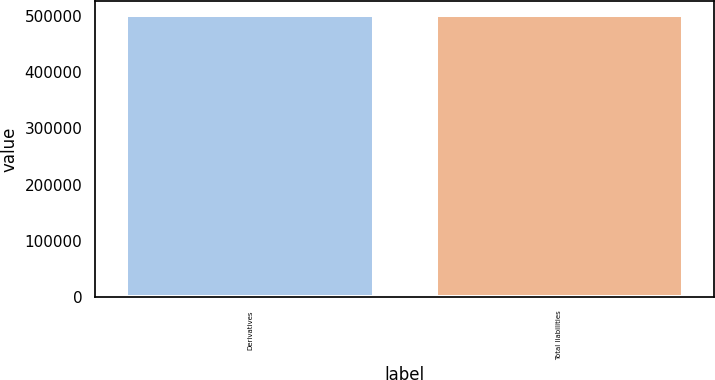<chart> <loc_0><loc_0><loc_500><loc_500><bar_chart><fcel>Derivatives<fcel>Total liabilities<nl><fcel>501726<fcel>501726<nl></chart> 